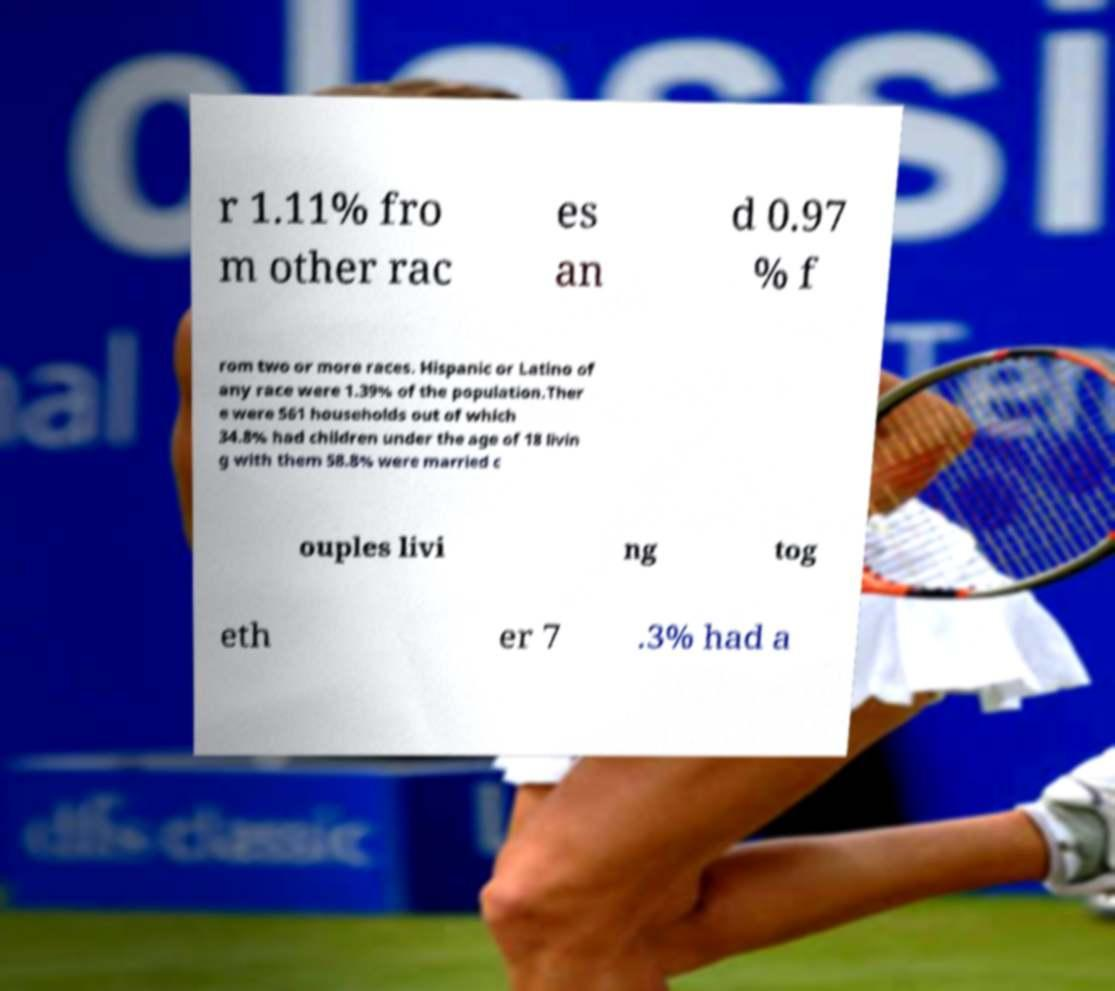There's text embedded in this image that I need extracted. Can you transcribe it verbatim? r 1.11% fro m other rac es an d 0.97 % f rom two or more races. Hispanic or Latino of any race were 1.39% of the population.Ther e were 561 households out of which 34.8% had children under the age of 18 livin g with them 58.8% were married c ouples livi ng tog eth er 7 .3% had a 